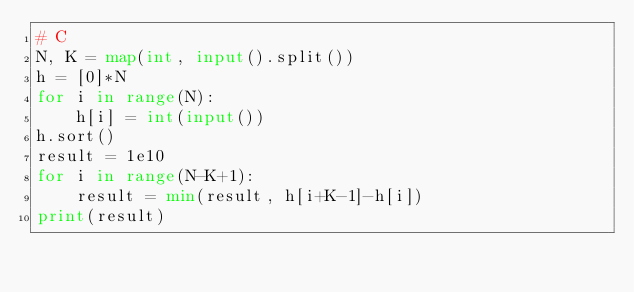<code> <loc_0><loc_0><loc_500><loc_500><_Python_># C
N, K = map(int, input().split())
h = [0]*N
for i in range(N):
    h[i] = int(input())
h.sort()
result = 1e10
for i in range(N-K+1):
    result = min(result, h[i+K-1]-h[i])
print(result)</code> 